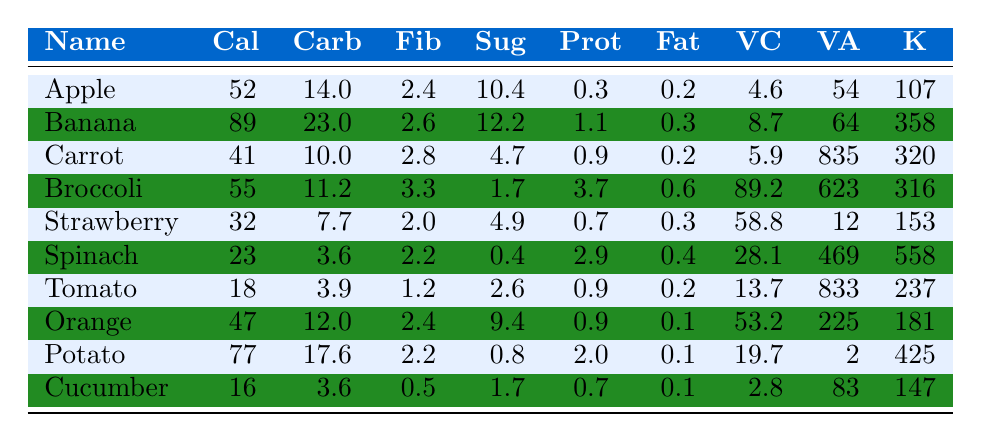What is the caloric content of a carrot? The table shows that a carrot has 41 calories listed under the "Cal" column.
Answer: 41 Which fruit has the highest sugar content? Looking at the "Sug" column, the banana has the highest sugar content at 12.2 grams.
Answer: Banana What is the total fiber content of an apple and an orange? The fiber content for an apple is 2.4 grams and for an orange is 2.4 grams. Adding these gives 2.4 + 2.4 = 4.8 grams.
Answer: 4.8 Which vegetable has the highest protein content? In the "Prot" column, broccoli has the highest protein content at 3.7 grams compared to other vegetables listed.
Answer: Broccoli Is the potassium content of spinach greater than that of a cucumber? The "K" column shows spinach has 558 mg and cucumber has 147 mg. Since 558 is greater than 147, the statement is true.
Answer: Yes What is the average vitamin C content of the listed fruits? The vitamin C content for the fruits is as follows: Apple (4.6), Banana (8.7), Strawberry (58.8), Orange (53.2). Summing these gives 4.6 + 8.7 + 58.8 + 53.2 = 125.3. Dividing by 4 gives an average of 125.3/4 = 31.325.
Answer: 31.3 Which has more calories, a potato or a cucumber? A potato has 77 calories, and a cucumber has 16 calories according to the "Cal" column. Since 77 is greater than 16, the potato has more calories.
Answer: Potato How much more potassium does a banana have than a tomato? From the table, banana has 358 mg and tomato has 237 mg of potassium. The difference is 358 - 237 = 121 mg.
Answer: 121 Is the fiber content of broccoli greater than that of an apple? The "Fib" column indicates broccoli has 3.3 grams of fiber and apple has 2.4 grams. Since 3.3 is greater than 2.4, the claim is true.
Answer: Yes What is the combined sugar content of a strawberry and a carrot? The sugar content for strawberry is 4.9 grams and for carrot is 4.7 grams. Adding these gives 4.9 + 4.7 = 9.6 grams of combined sugar content.
Answer: 9.6 